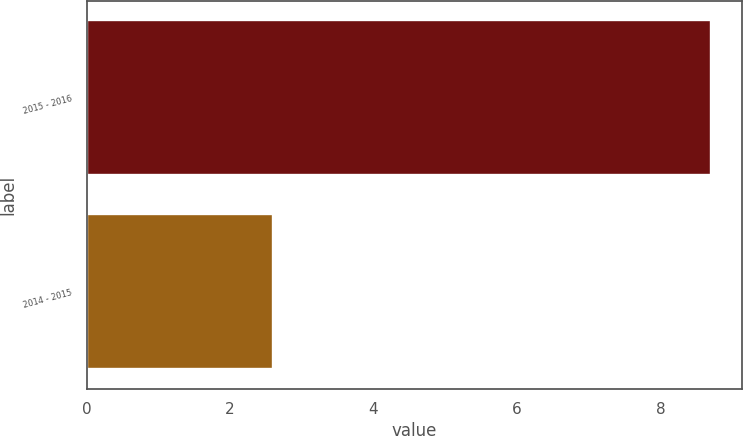<chart> <loc_0><loc_0><loc_500><loc_500><bar_chart><fcel>2015 - 2016<fcel>2014 - 2015<nl><fcel>8.7<fcel>2.6<nl></chart> 